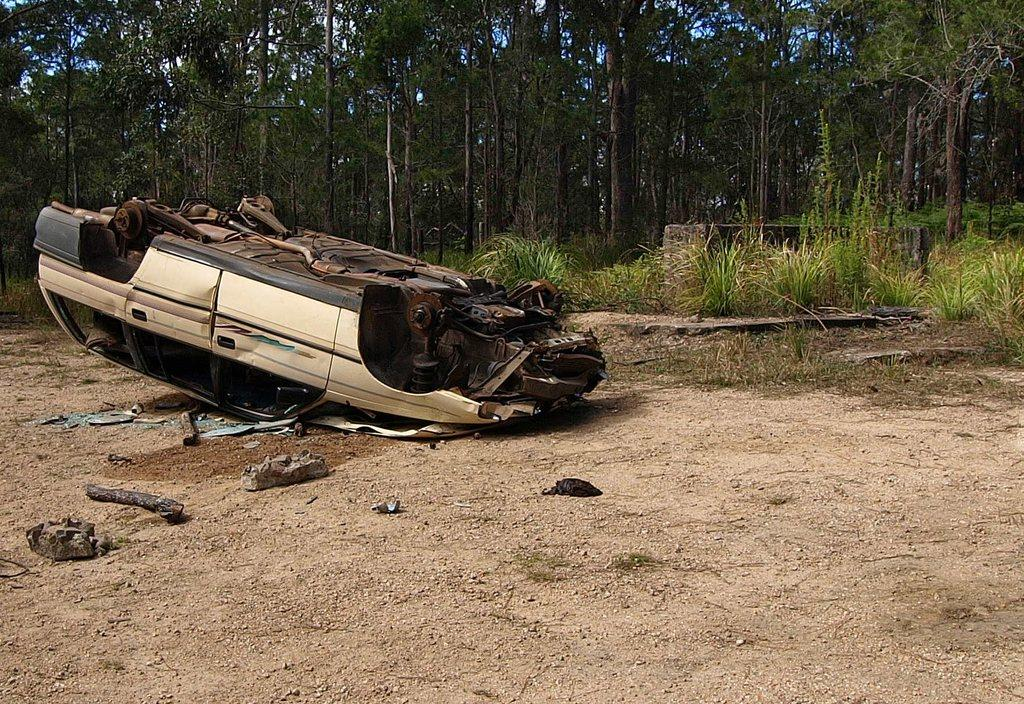What is the main subject of the image? There is a car in the image. How is the car positioned in the image? The car is upside down on the ground. What type of vegetation can be seen on the ground? There are small plants on the ground. What can be seen in the background of the image? There are tall trees visible in the image. What is the color of the trees? The trees are green in color. What type of sack can be seen hanging from the tree in the image? There is no sack hanging from the tree in the image; only tall green trees are visible in the background. How does the car express its feelings of hate in the image? The car is an inanimate object and does not have feelings or the ability to express emotions like hate. 